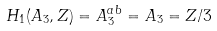<formula> <loc_0><loc_0><loc_500><loc_500>H _ { 1 } ( A _ { 3 } , Z ) = A _ { 3 } ^ { a b } = A _ { 3 } = Z / 3</formula> 